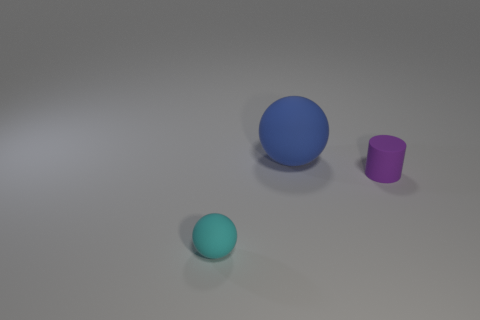Is there any other thing that is the same size as the blue matte sphere?
Your response must be concise. No. The matte ball behind the sphere in front of the big thing is what color?
Provide a succinct answer. Blue. How many matte things are small green cylinders or tiny objects?
Make the answer very short. 2. Are there any small purple cylinders that have the same material as the small cyan ball?
Keep it short and to the point. Yes. How many things are in front of the purple rubber thing and behind the purple thing?
Offer a very short reply. 0. Are there fewer blue rubber spheres that are in front of the small cyan ball than balls in front of the blue rubber object?
Keep it short and to the point. Yes. Is the cyan thing the same shape as the blue rubber thing?
Give a very brief answer. Yes. What number of other things are the same size as the purple rubber cylinder?
Give a very brief answer. 1. How many objects are big things behind the small cyan thing or tiny cyan objects left of the purple matte cylinder?
Ensure brevity in your answer.  2. How many big blue things have the same shape as the small cyan thing?
Keep it short and to the point. 1. 